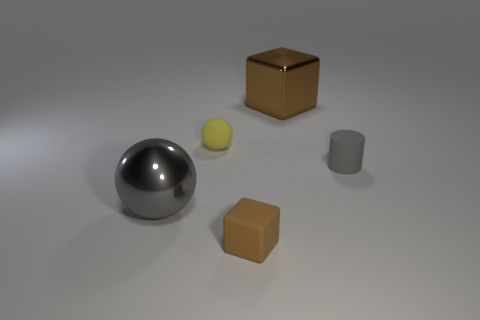There is a brown object that is on the right side of the brown thing that is left of the big object that is on the right side of the big gray object; what is its shape? cube 